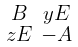Convert formula to latex. <formula><loc_0><loc_0><loc_500><loc_500>\begin{smallmatrix} B & y E \\ z E & - A \end{smallmatrix}</formula> 